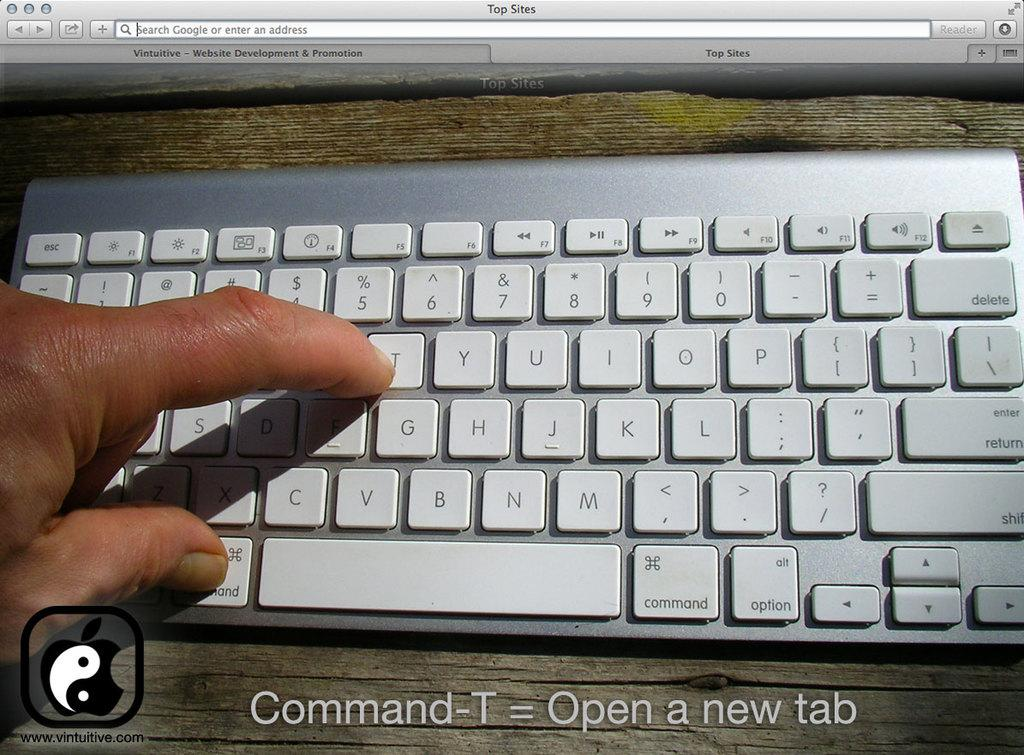<image>
Give a short and clear explanation of the subsequent image. Person pointing to letter T on a key board. 